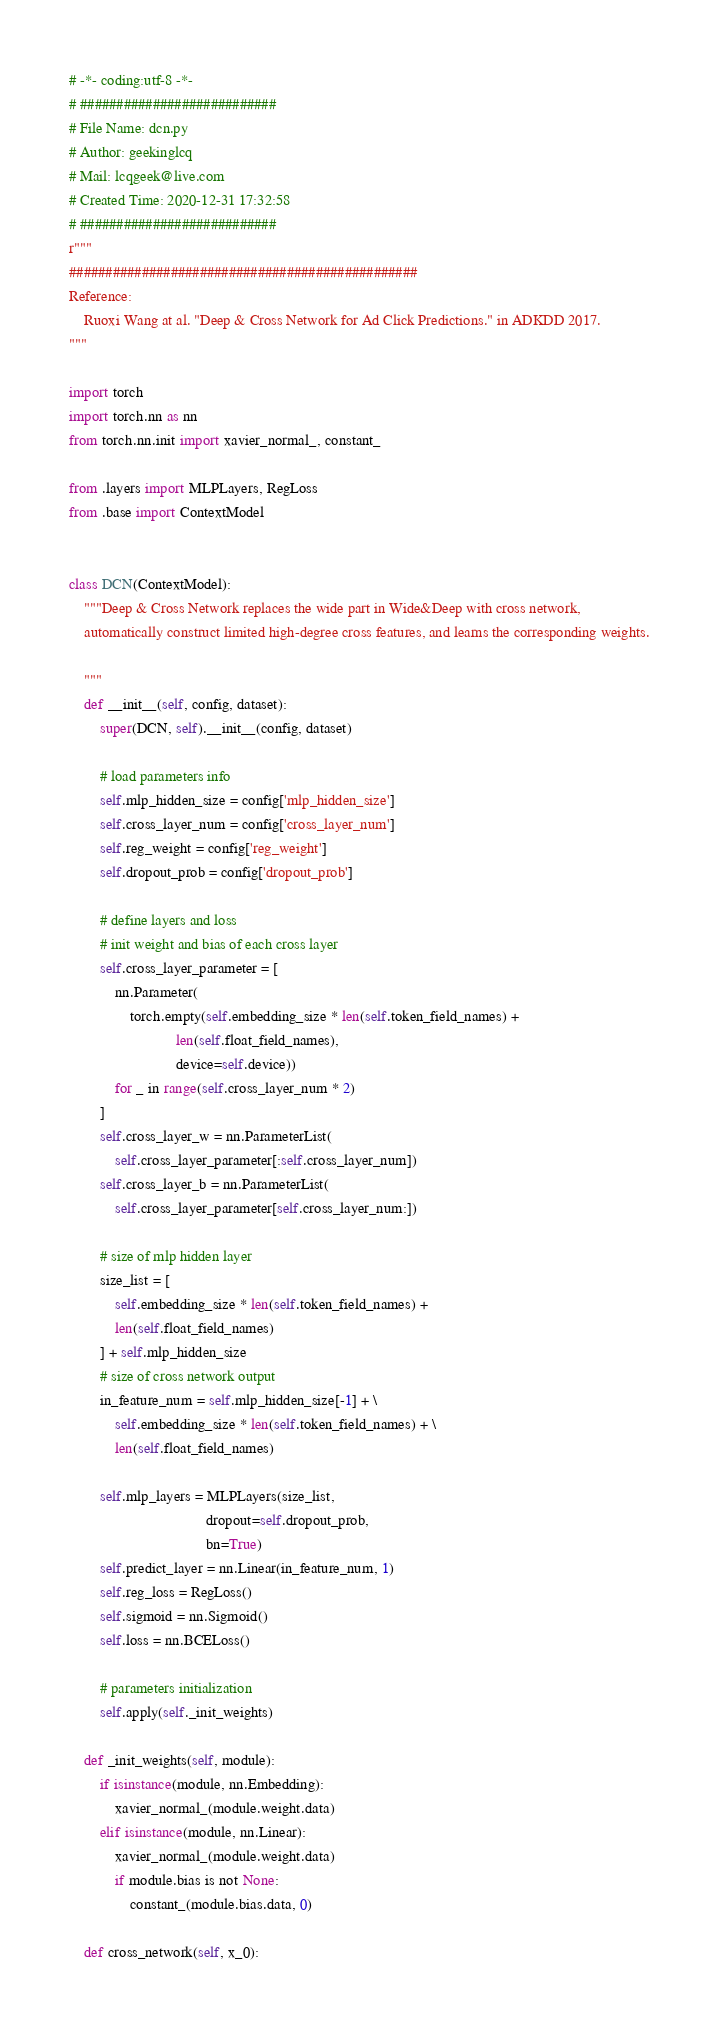Convert code to text. <code><loc_0><loc_0><loc_500><loc_500><_Python_># -*- coding:utf-8 -*-
# ###########################
# File Name: dcn.py
# Author: geekinglcq
# Mail: lcqgeek@live.com
# Created Time: 2020-12-31 17:32:58
# ###########################
r"""
################################################
Reference:
    Ruoxi Wang at al. "Deep & Cross Network for Ad Click Predictions." in ADKDD 2017.
"""

import torch
import torch.nn as nn
from torch.nn.init import xavier_normal_, constant_

from .layers import MLPLayers, RegLoss
from .base import ContextModel


class DCN(ContextModel):
    """Deep & Cross Network replaces the wide part in Wide&Deep with cross network,
    automatically construct limited high-degree cross features, and learns the corresponding weights.

    """
    def __init__(self, config, dataset):
        super(DCN, self).__init__(config, dataset)

        # load parameters info
        self.mlp_hidden_size = config['mlp_hidden_size']
        self.cross_layer_num = config['cross_layer_num']
        self.reg_weight = config['reg_weight']
        self.dropout_prob = config['dropout_prob']

        # define layers and loss
        # init weight and bias of each cross layer
        self.cross_layer_parameter = [
            nn.Parameter(
                torch.empty(self.embedding_size * len(self.token_field_names) +
                            len(self.float_field_names),
                            device=self.device))
            for _ in range(self.cross_layer_num * 2)
        ]
        self.cross_layer_w = nn.ParameterList(
            self.cross_layer_parameter[:self.cross_layer_num])
        self.cross_layer_b = nn.ParameterList(
            self.cross_layer_parameter[self.cross_layer_num:])

        # size of mlp hidden layer
        size_list = [
            self.embedding_size * len(self.token_field_names) +
            len(self.float_field_names)
        ] + self.mlp_hidden_size
        # size of cross network output
        in_feature_num = self.mlp_hidden_size[-1] + \
            self.embedding_size * len(self.token_field_names) + \
            len(self.float_field_names)

        self.mlp_layers = MLPLayers(size_list,
                                    dropout=self.dropout_prob,
                                    bn=True)
        self.predict_layer = nn.Linear(in_feature_num, 1)
        self.reg_loss = RegLoss()
        self.sigmoid = nn.Sigmoid()
        self.loss = nn.BCELoss()

        # parameters initialization
        self.apply(self._init_weights)

    def _init_weights(self, module):
        if isinstance(module, nn.Embedding):
            xavier_normal_(module.weight.data)
        elif isinstance(module, nn.Linear):
            xavier_normal_(module.weight.data)
            if module.bias is not None:
                constant_(module.bias.data, 0)

    def cross_network(self, x_0):</code> 